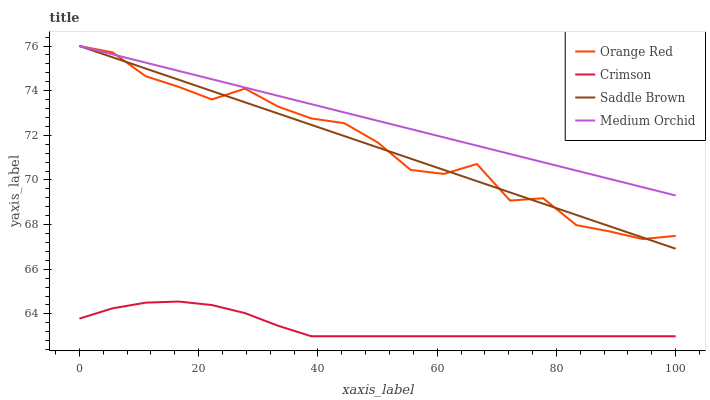Does Crimson have the minimum area under the curve?
Answer yes or no. Yes. Does Medium Orchid have the maximum area under the curve?
Answer yes or no. Yes. Does Orange Red have the minimum area under the curve?
Answer yes or no. No. Does Orange Red have the maximum area under the curve?
Answer yes or no. No. Is Saddle Brown the smoothest?
Answer yes or no. Yes. Is Orange Red the roughest?
Answer yes or no. Yes. Is Medium Orchid the smoothest?
Answer yes or no. No. Is Medium Orchid the roughest?
Answer yes or no. No. Does Orange Red have the lowest value?
Answer yes or no. No. Is Crimson less than Medium Orchid?
Answer yes or no. Yes. Is Orange Red greater than Crimson?
Answer yes or no. Yes. Does Crimson intersect Medium Orchid?
Answer yes or no. No. 